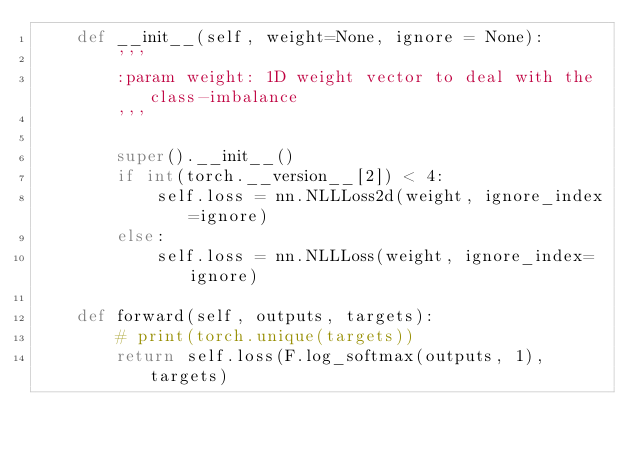<code> <loc_0><loc_0><loc_500><loc_500><_Python_>    def __init__(self, weight=None, ignore = None):
        '''
        :param weight: 1D weight vector to deal with the class-imbalance
        '''

        super().__init__()
        if int(torch.__version__[2]) < 4:
            self.loss = nn.NLLLoss2d(weight, ignore_index=ignore)
        else:
            self.loss = nn.NLLLoss(weight, ignore_index=ignore)

    def forward(self, outputs, targets):
        # print(torch.unique(targets))
        return self.loss(F.log_softmax(outputs, 1), targets)</code> 